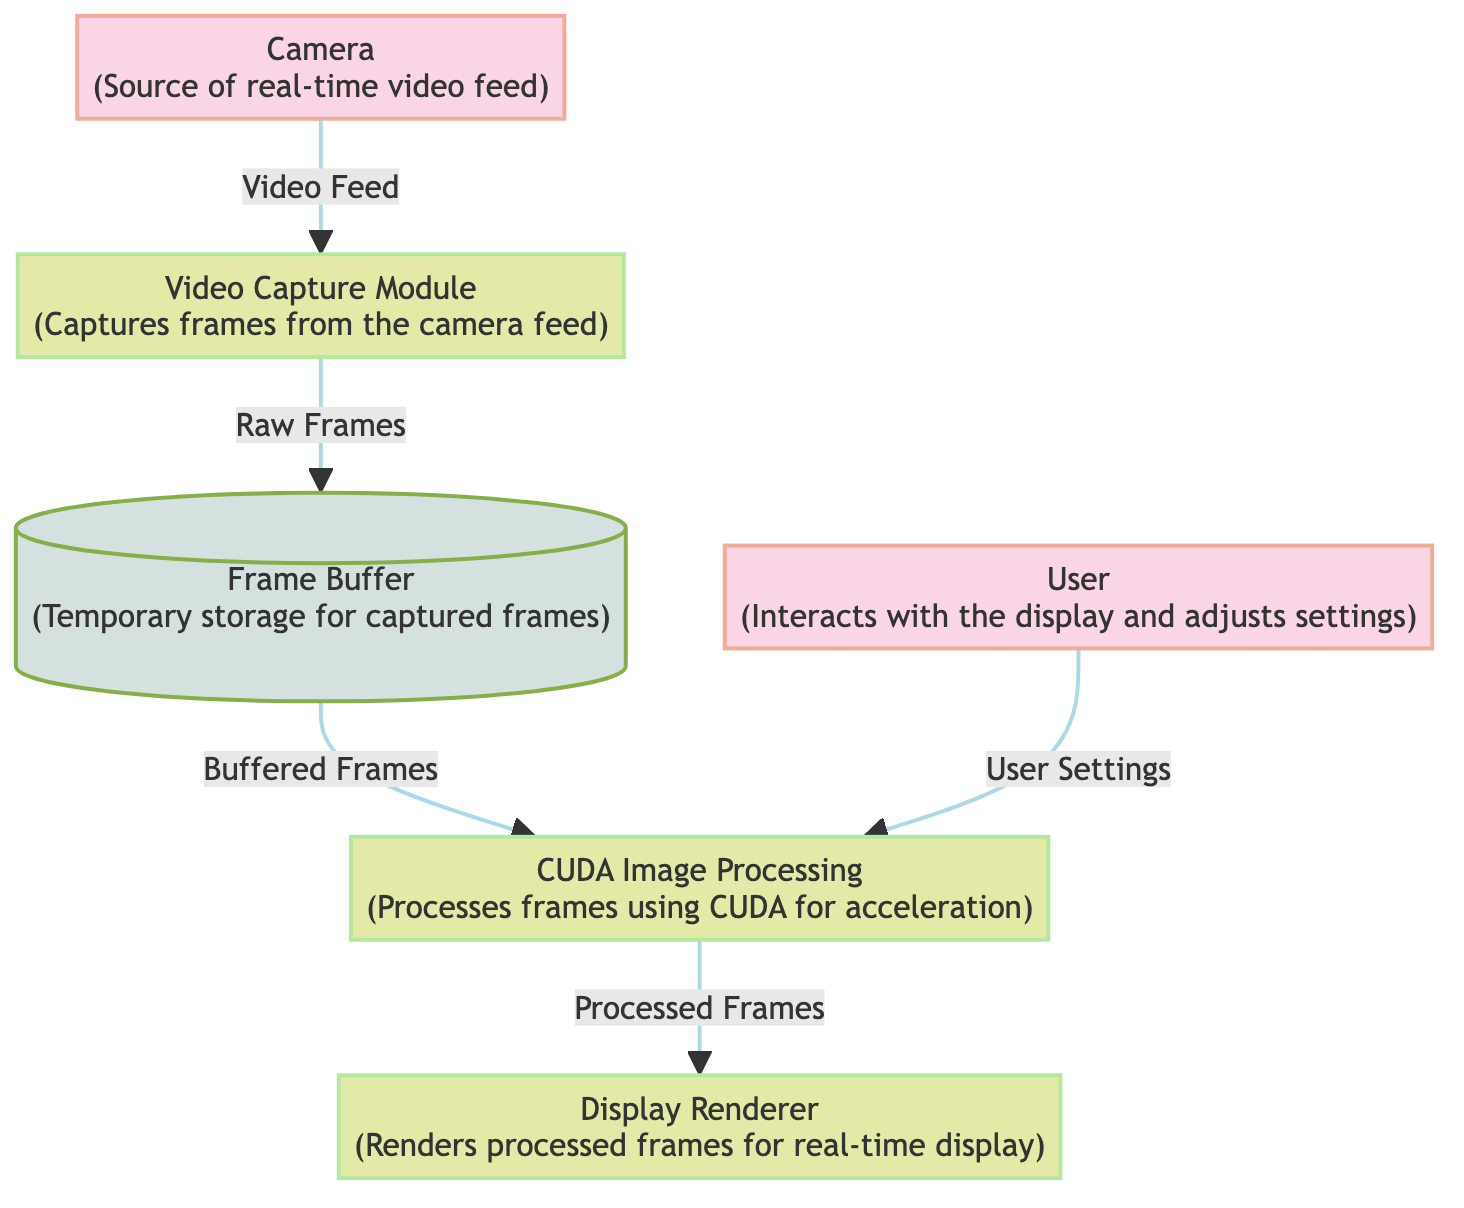What is the role of the Camera in this workflow? The Camera serves as the source of the real-time video feed, which is the starting point of the data flow in the diagram.
Answer: Source of real-time video feed How many processes are there in the diagram? The diagram features four processes: Video Capture Module, CUDA Image Processing, Display Renderer, and User Settings.
Answer: Four What is the data flow from the Video Capture Module to the Frame Buffer? The data flow is named Raw Frames, indicating the type of data being transferred between these two nodes.
Answer: Raw Frames Which module processes the frames using CUDA? The module responsible for processing frames with CUDA is called CUDA Image Processing.
Answer: CUDA Image Processing What type of entity is the User in the diagram? The User is classified as an external entity, indicating that it interacts with the workflow but is not part of the internal processes.
Answer: External entity What is the primary function of the Display Renderer? The Display Renderer is tasked with rendering processed frames for real-time display, showcasing the output of continuous processing.
Answer: Renders processed frames for real-time display Which component stores captured frames temporarily before processing? The temporary storage for captured frames is implemented through the Frame Buffer, which acts as a data store in the diagram.
Answer: Frame Buffer What is the immediate data flow that occurs after the CUDA Image Processing module? The immediate data flow after the CUDA Image Processing module is from it to the Display Renderer, carrying the processed frames.
Answer: Processed Frames What settings does the User provide to the CUDA Image Processing module? The User provides User Settings to the CUDA Image Processing module, influencing how frames are processed.
Answer: User Settings 